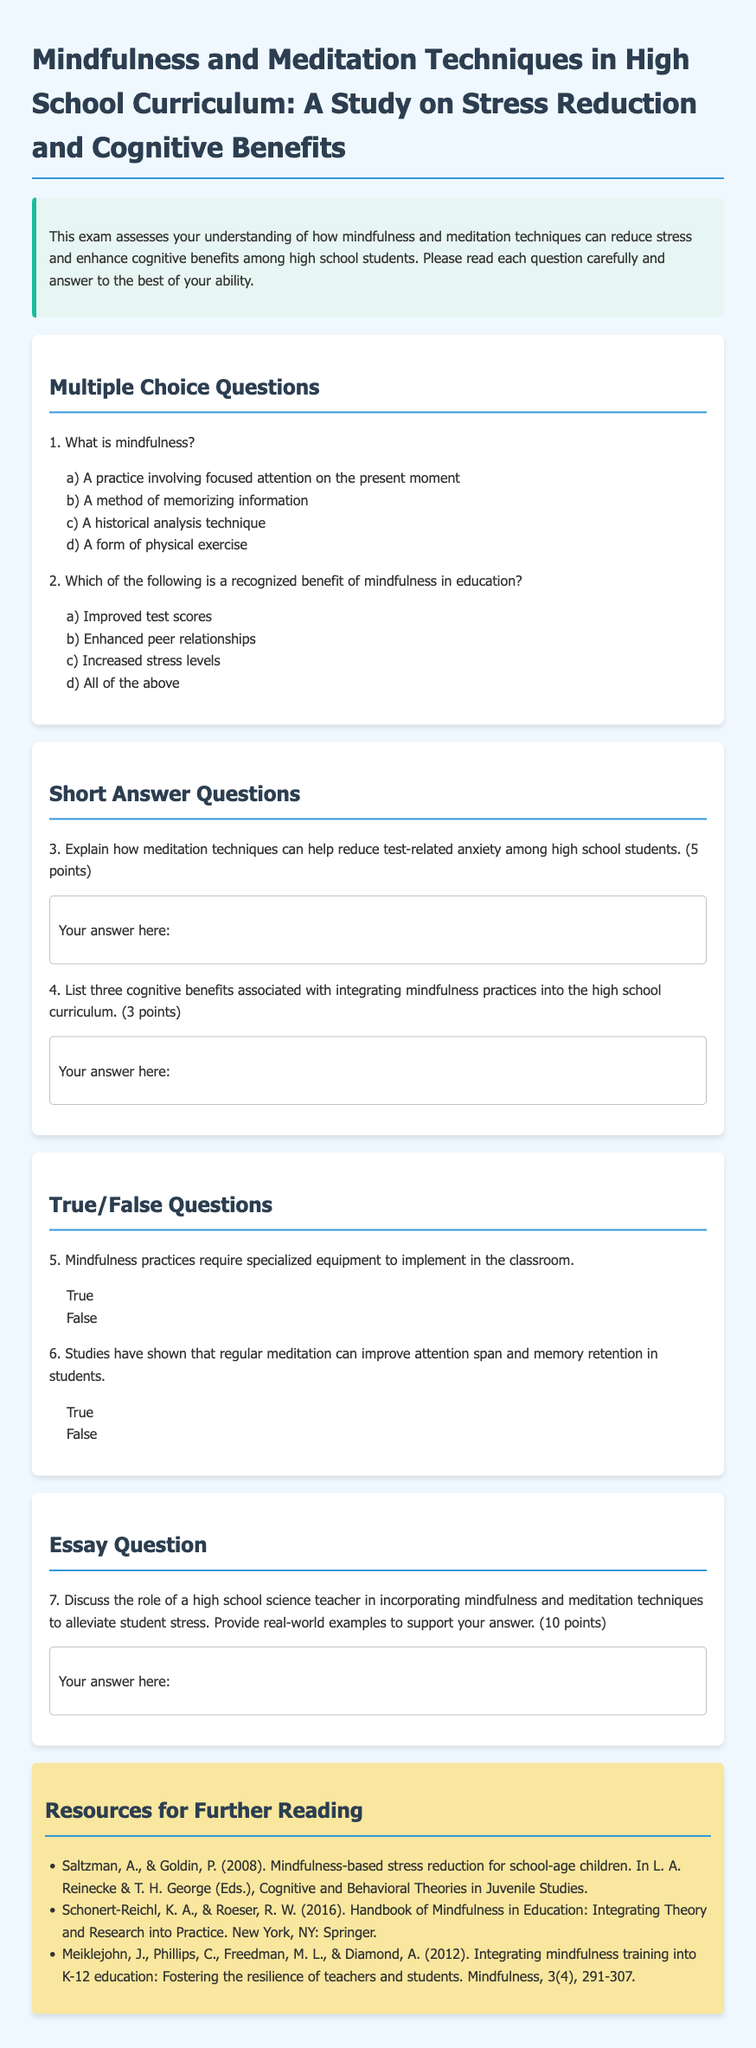What is the title of the exam? The title is provided in the header of the document.
Answer: Mindfulness and Meditation Techniques in High School Curriculum: A Study on Stress Reduction and Cognitive Benefits How many multiple choice questions are there? The number of multiple choice questions can be counted in the relevant section.
Answer: 2 What is one recognized benefit of mindfulness in education? The answer appears in the multiple choice options provided in the document.
Answer: Improved test scores What does the essay question assess? The content in the essay question indicates what it evaluates.
Answer: Role of a high school science teacher How many points is the short answer question worth where students explain reduction of test-related anxiety? The points associated with the short answer question is stated directly in the question.
Answer: 5 points Is specialized equipment required to implement mindfulness practices in the classroom? The true/false question requires a binary response based on the document's information.
Answer: False What year was the Handbook of Mindfulness in Education published? The publication year can be found in the resource section of the document.
Answer: 2016 What is one cognitive benefit mentioned in the short answer section? The answer can be inferred from the question requirement for listing benefits.
Answer: Improved attention span Which resource focuses on integrating mindfulness training into K-12 education? The specific resource can be identified based on the titles listed in the document.
Answer: Integrating mindfulness training into K-12 education: Fostering the resilience of teachers and students What is the color of the introduction background? The color is specifically mentioned in the styling of the introduction section.
Answer: Light blue 